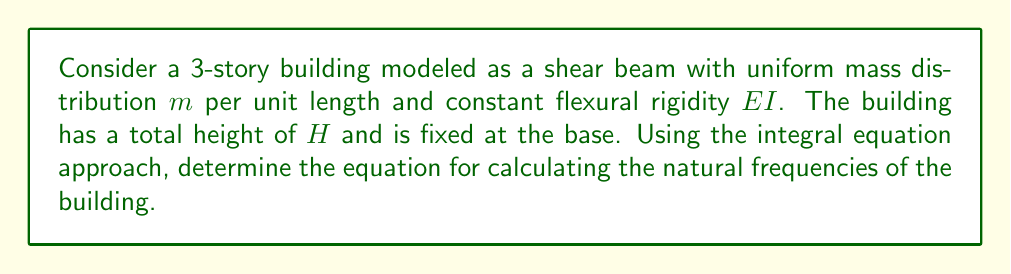Can you answer this question? To solve this problem, we'll follow these steps:

1) First, we need to set up the governing differential equation for the shear beam model:

   $$EI \frac{\partial^4 y}{\partial x^4} + m \frac{\partial^2 y}{\partial t^2} = 0$$

   where $y(x,t)$ is the lateral displacement at height $x$ and time $t$.

2) Assume a solution of the form $y(x,t) = Y(x)e^{i\omega t}$, where $\omega$ is the natural frequency and $Y(x)$ is the mode shape.

3) Substituting this into the governing equation:

   $$EI \frac{d^4 Y}{dx^4} - m\omega^2 Y = 0$$

4) Define $\lambda^4 = \frac{m\omega^2}{EI}$. The general solution for $Y(x)$ is:

   $$Y(x) = A\sin(\lambda x) + B\cos(\lambda x) + C\sinh(\lambda x) + D\cosh(\lambda x)$$

5) Apply the boundary conditions:
   - At $x=0$ (fixed base): $Y(0) = 0$ and $Y'(0) = 0$
   - At $x=H$ (free top): $Y''(H) = 0$ and $Y'''(H) = 0$

6) The first two conditions give $B = -D$ and $A = -C$. Substituting these into the general solution:

   $$Y(x) = A[\sin(\lambda x) - \sinh(\lambda x)] + B[\cos(\lambda x) - \cosh(\lambda x)]$$

7) Applying the remaining two boundary conditions leads to the frequency equation:

   $$\cos(\lambda H)\cosh(\lambda H) = -1$$

8) The solutions to this equation give the values of $\lambda H$ for each mode. The natural frequencies can then be calculated using:

   $$\omega_n = \frac{(\lambda_n H)^2}{H^2}\sqrt{\frac{EI}{m}}$$

   where $\lambda_n H$ is the $n$-th solution to the frequency equation.
Answer: $\omega_n = \frac{(\lambda_n H)^2}{H^2}\sqrt{\frac{EI}{m}}$, where $\lambda_n H$ satisfies $\cos(\lambda H)\cosh(\lambda H) = -1$ 